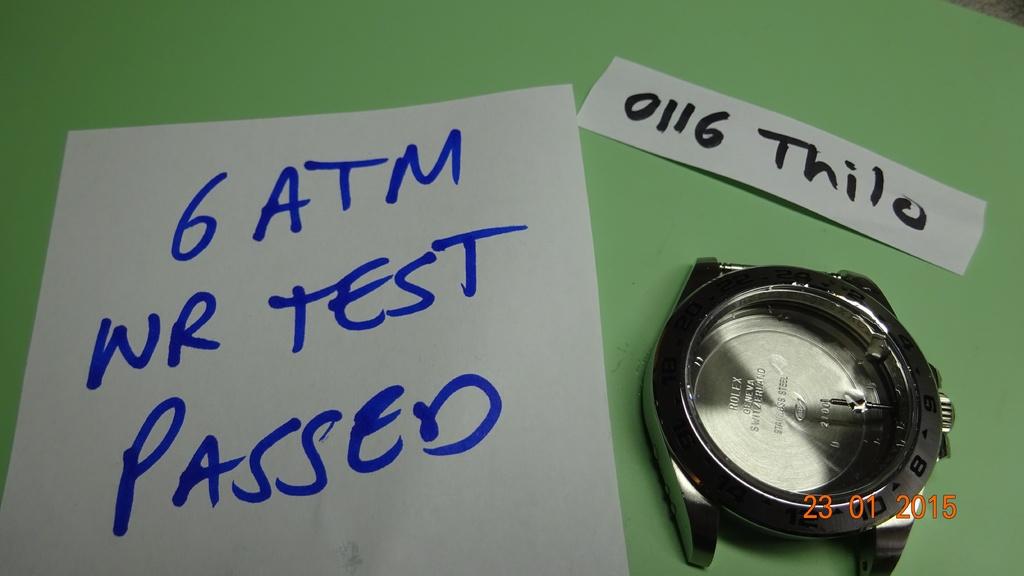Was the test passed or failed?
Your answer should be compact. Passed. 